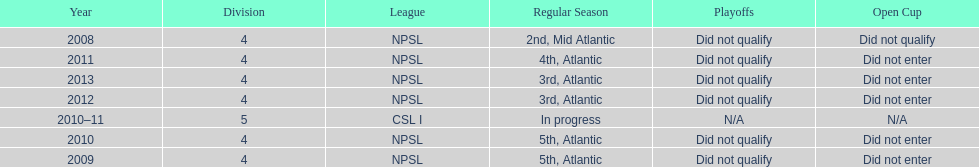In what year only did they compete in division 5 2010-11. 